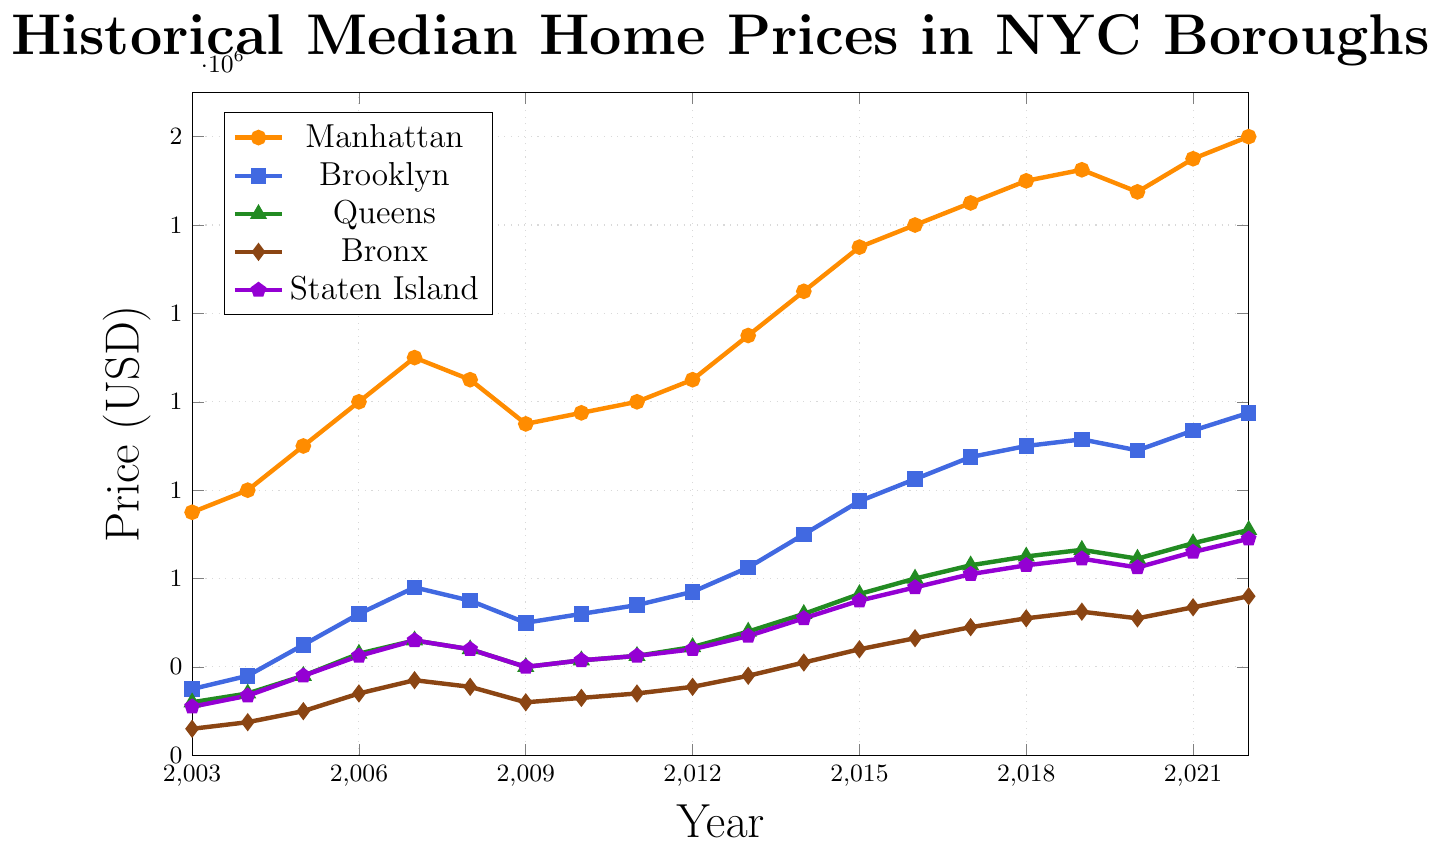Which borough had the highest median home price in 2018? To find the borough with the highest median home price in 2018, find the data point for each borough in that year and identify the maximum value. Manhattan has the highest value at $1,500,000.
Answer: Manhattan What is the difference in the median home prices between Brooklyn and Queens in 2006? Subtract the median home price of Queens from that of Brooklyn in 2006. Brooklyn's price is $520,000 and Queens' price is $430,000. Thus, the difference is $520,000 - $430,000 = $90,000.
Answer: $90,000 How did the median home price in the Bronx change from 2008 to 2009? By observing the plotted line for the Bronx, you can see the median home price. In 2008, it was $355,000 and in 2009, it was $320,000. The change is $320,000 - $355,000 = -$35,000, indicating a decrease.
Answer: Decreased by $35,000 What was the median home price in Manhattan in the year the financial crisis hit its lowest point? The financial crisis is typically marked by a low point in 2009. The plotted data for Manhattan in 2009 shows a median home price of $950,000.
Answer: $950,000 In which year did Staten Island surpass the median home price of $500,000? Look at the trend line for Staten Island and identify the year where the median home price first exceeds $500,000. This happens in 2014.
Answer: 2014 What is the trend in home prices for Brooklyn between 2019 and 2021? In 2019, the median home price in Brooklyn was $915,000. It dipped to $890,000 in 2020 and rose again to $935,000 in 2021. The trend shows a decrease followed by an increase.
Answer: Decrease and then increase 